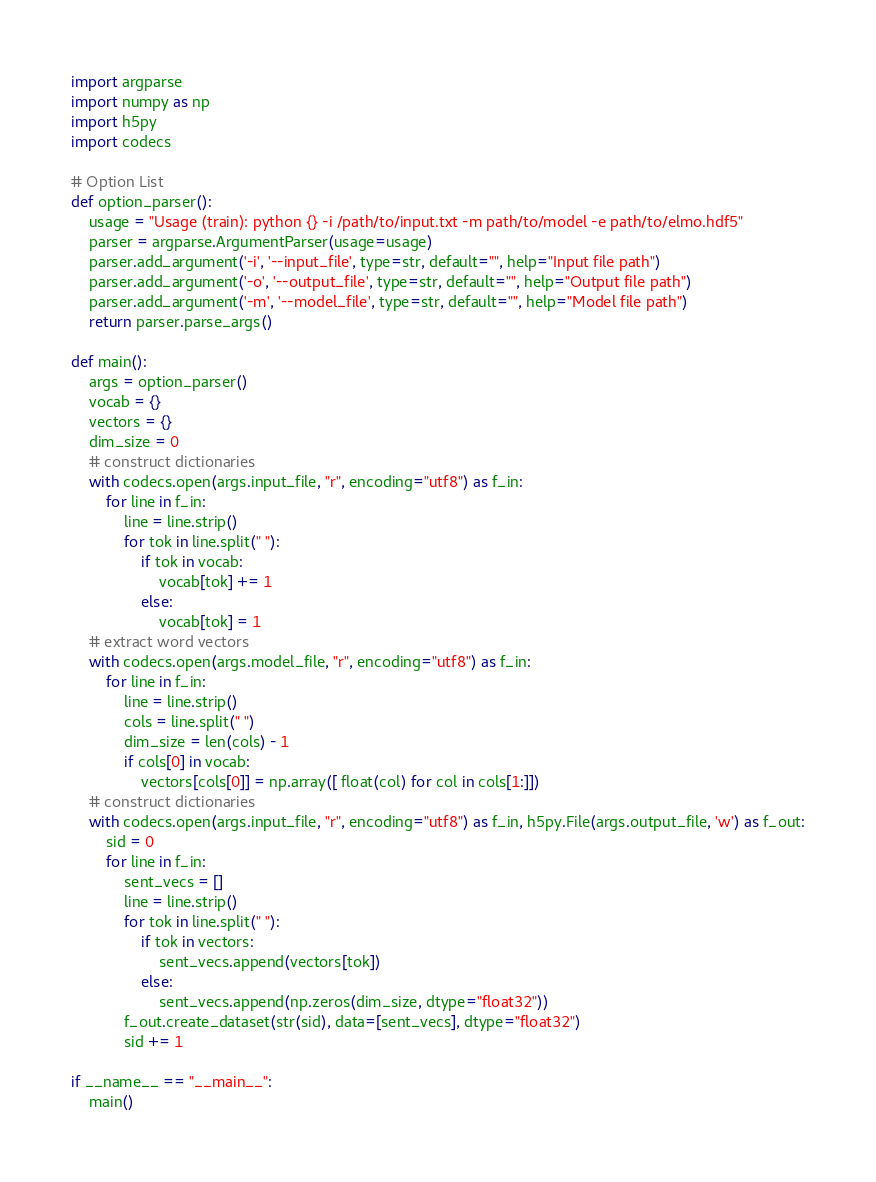Convert code to text. <code><loc_0><loc_0><loc_500><loc_500><_Python_>import argparse
import numpy as np
import h5py
import codecs

# Option List
def option_parser():
    usage = "Usage (train): python {} -i /path/to/input.txt -m path/to/model -e path/to/elmo.hdf5"
    parser = argparse.ArgumentParser(usage=usage)
    parser.add_argument('-i', '--input_file', type=str, default="", help="Input file path")
    parser.add_argument('-o', '--output_file', type=str, default="", help="Output file path")
    parser.add_argument('-m', '--model_file', type=str, default="", help="Model file path")
    return parser.parse_args()

def main():
    args = option_parser()
    vocab = {}
    vectors = {}
    dim_size = 0
    # construct dictionaries
    with codecs.open(args.input_file, "r", encoding="utf8") as f_in:
        for line in f_in:
            line = line.strip()
            for tok in line.split(" "):
                if tok in vocab:
                    vocab[tok] += 1
                else:
                    vocab[tok] = 1
    # extract word vectors
    with codecs.open(args.model_file, "r", encoding="utf8") as f_in:
        for line in f_in:
            line = line.strip()
            cols = line.split(" ")
            dim_size = len(cols) - 1
            if cols[0] in vocab:
                vectors[cols[0]] = np.array([ float(col) for col in cols[1:]])
    # construct dictionaries
    with codecs.open(args.input_file, "r", encoding="utf8") as f_in, h5py.File(args.output_file, 'w') as f_out:
        sid = 0
        for line in f_in:
            sent_vecs = []
            line = line.strip()
            for tok in line.split(" "):
                if tok in vectors:
                    sent_vecs.append(vectors[tok])
                else:
                    sent_vecs.append(np.zeros(dim_size, dtype="float32"))
            f_out.create_dataset(str(sid), data=[sent_vecs], dtype="float32")
            sid += 1

if __name__ == "__main__":
    main()
</code> 